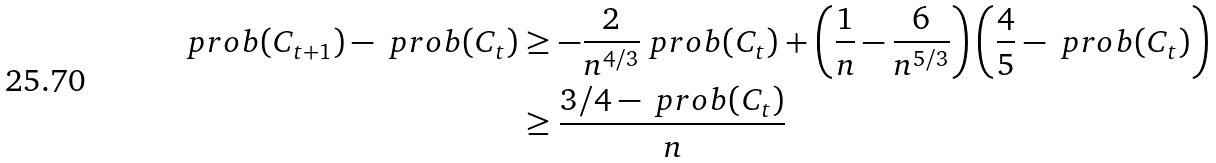Convert formula to latex. <formula><loc_0><loc_0><loc_500><loc_500>\ p r o b ( C _ { t + 1 } ) - \ p r o b ( C _ { t } ) & \geq - \frac { 2 } { n ^ { 4 / 3 } } \ p r o b ( C _ { t } ) + \left ( \frac { 1 } { n } - \frac { 6 } { n ^ { 5 / 3 } } \right ) \left ( \frac { 4 } { 5 } - \ p r o b ( C _ { t } ) \right ) \\ & \geq \frac { 3 / 4 - \ p r o b ( C _ { t } ) } { n }</formula> 